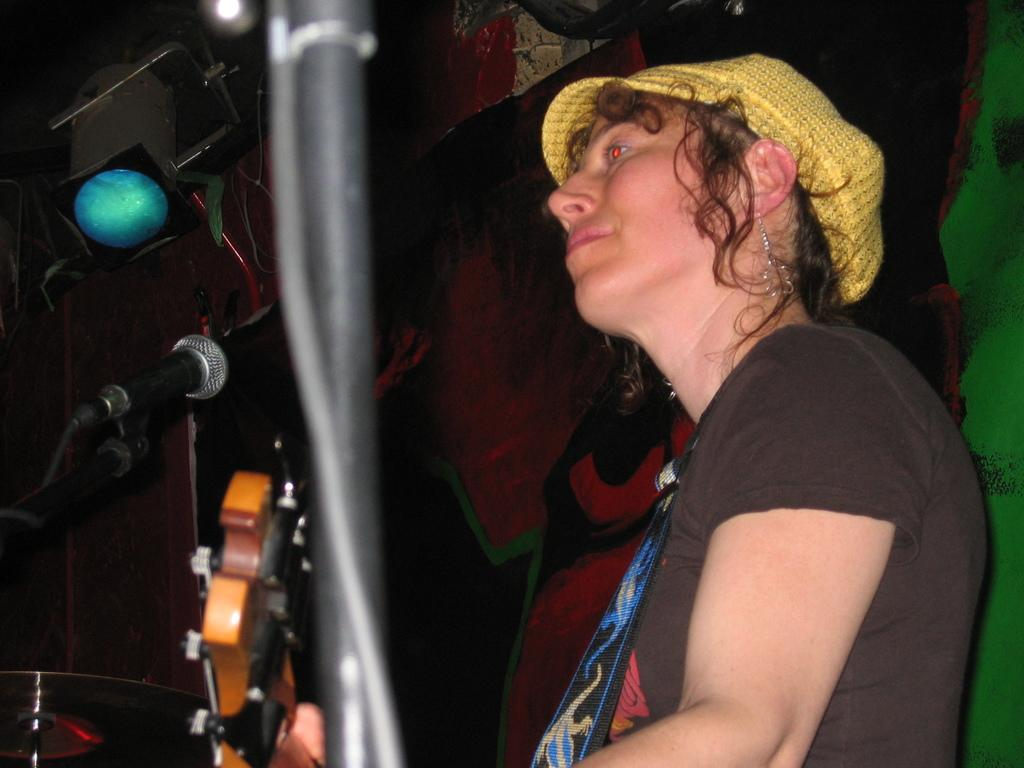Who is the main subject in the image? There is a woman in the image. What is the woman wearing? The woman is wearing a black t-shirt. What expression does the woman have? The woman is smiling. What is the woman doing in the image? The woman is playing with a wooden guitar. What can be seen in the background of the image? There is a blue color spotlight visible in the image. What type of eggnog is being distributed by the woman in the image? There is no eggnog present in the image, and the woman is not distributing anything. 